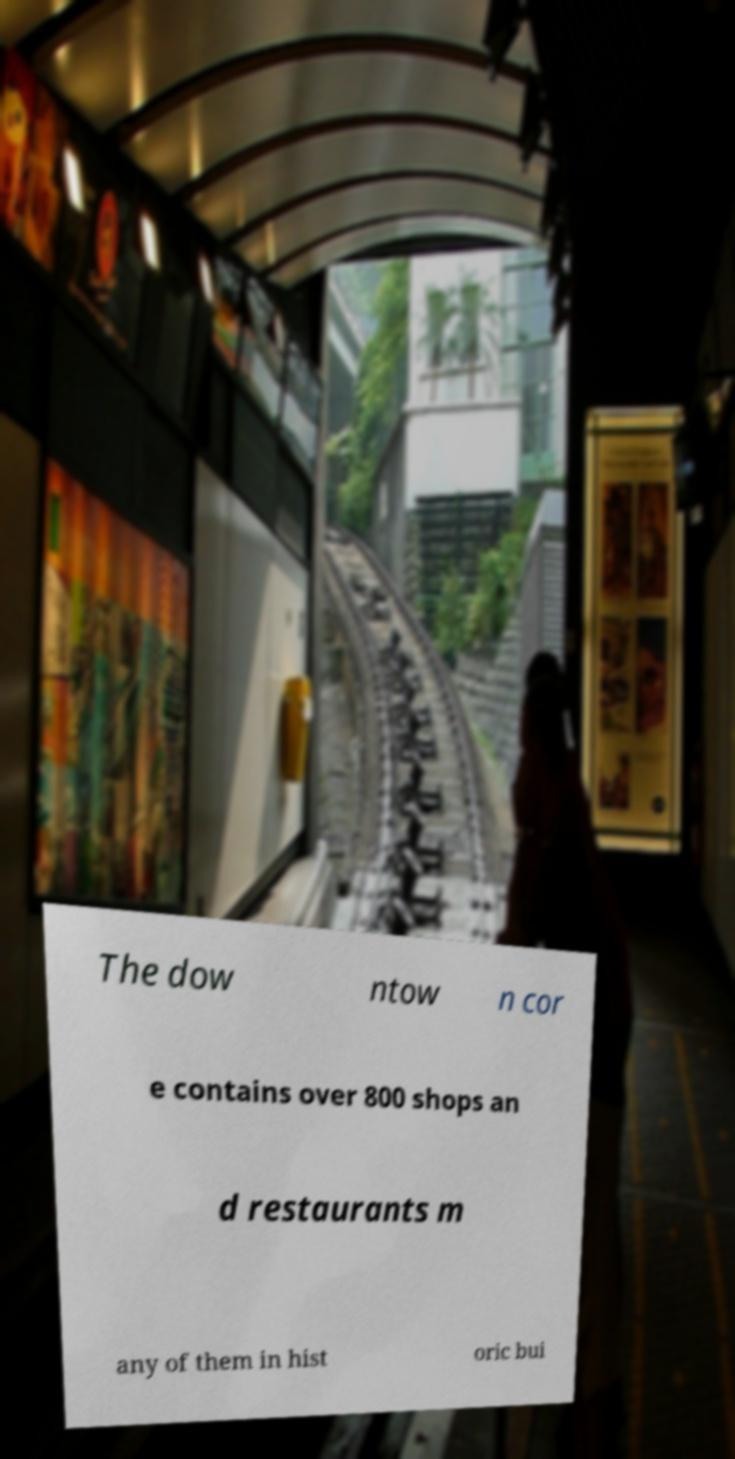Could you assist in decoding the text presented in this image and type it out clearly? The dow ntow n cor e contains over 800 shops an d restaurants m any of them in hist oric bui 